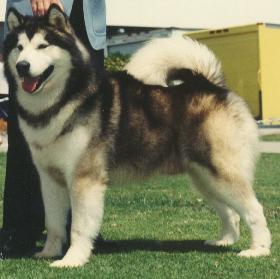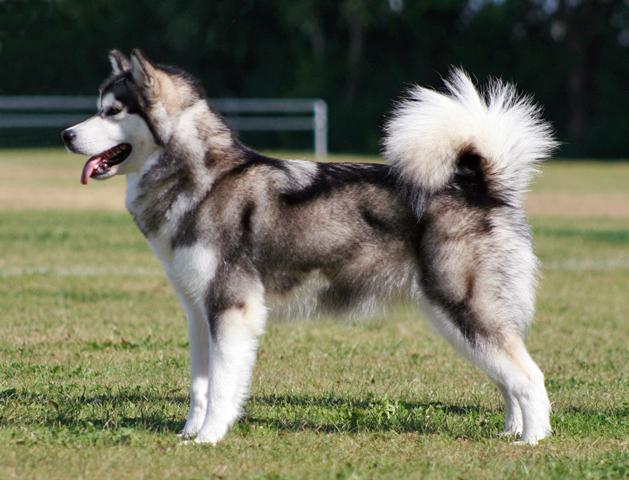The first image is the image on the left, the second image is the image on the right. Given the left and right images, does the statement "Both dogs have their mouths open." hold true? Answer yes or no. Yes. 